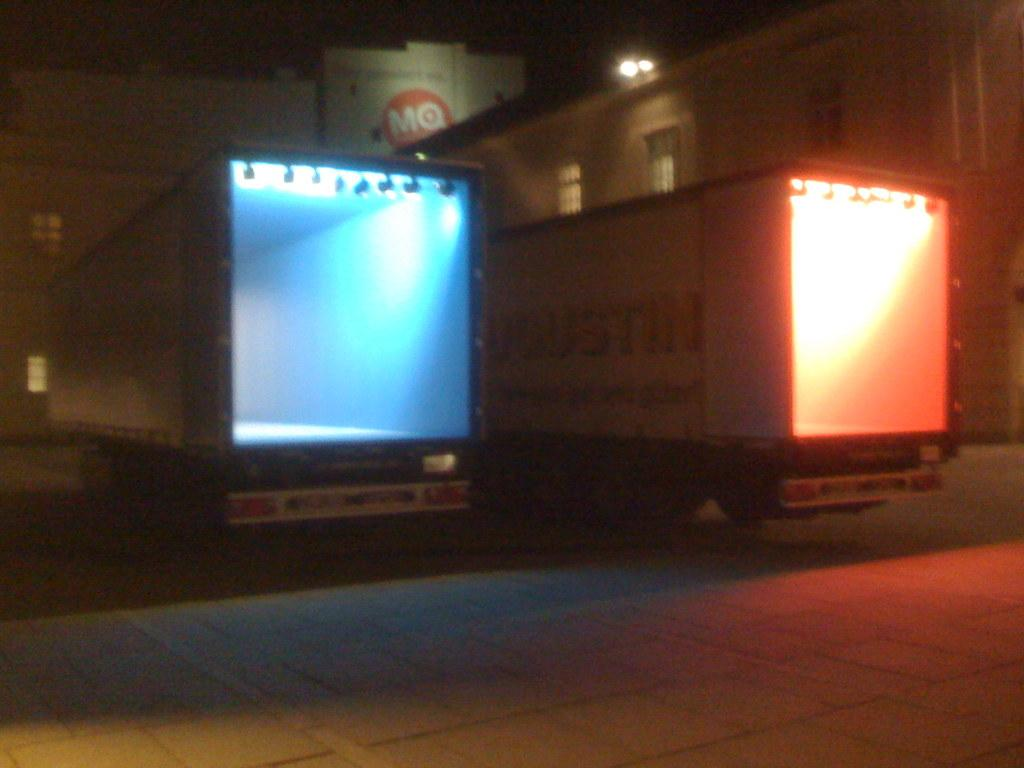Provide a one-sentence caption for the provided image. Two large trucks are parked in front of a building with the letters MQ on it. 